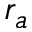Convert formula to latex. <formula><loc_0><loc_0><loc_500><loc_500>r _ { a }</formula> 